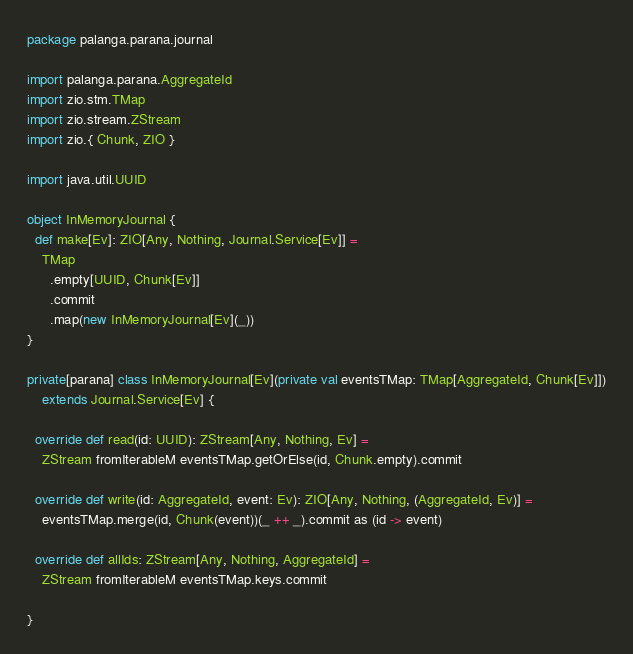Convert code to text. <code><loc_0><loc_0><loc_500><loc_500><_Scala_>package palanga.parana.journal

import palanga.parana.AggregateId
import zio.stm.TMap
import zio.stream.ZStream
import zio.{ Chunk, ZIO }

import java.util.UUID

object InMemoryJournal {
  def make[Ev]: ZIO[Any, Nothing, Journal.Service[Ev]] =
    TMap
      .empty[UUID, Chunk[Ev]]
      .commit
      .map(new InMemoryJournal[Ev](_))
}

private[parana] class InMemoryJournal[Ev](private val eventsTMap: TMap[AggregateId, Chunk[Ev]])
    extends Journal.Service[Ev] {

  override def read(id: UUID): ZStream[Any, Nothing, Ev] =
    ZStream fromIterableM eventsTMap.getOrElse(id, Chunk.empty).commit

  override def write(id: AggregateId, event: Ev): ZIO[Any, Nothing, (AggregateId, Ev)] =
    eventsTMap.merge(id, Chunk(event))(_ ++ _).commit as (id -> event)

  override def allIds: ZStream[Any, Nothing, AggregateId] =
    ZStream fromIterableM eventsTMap.keys.commit

}
</code> 